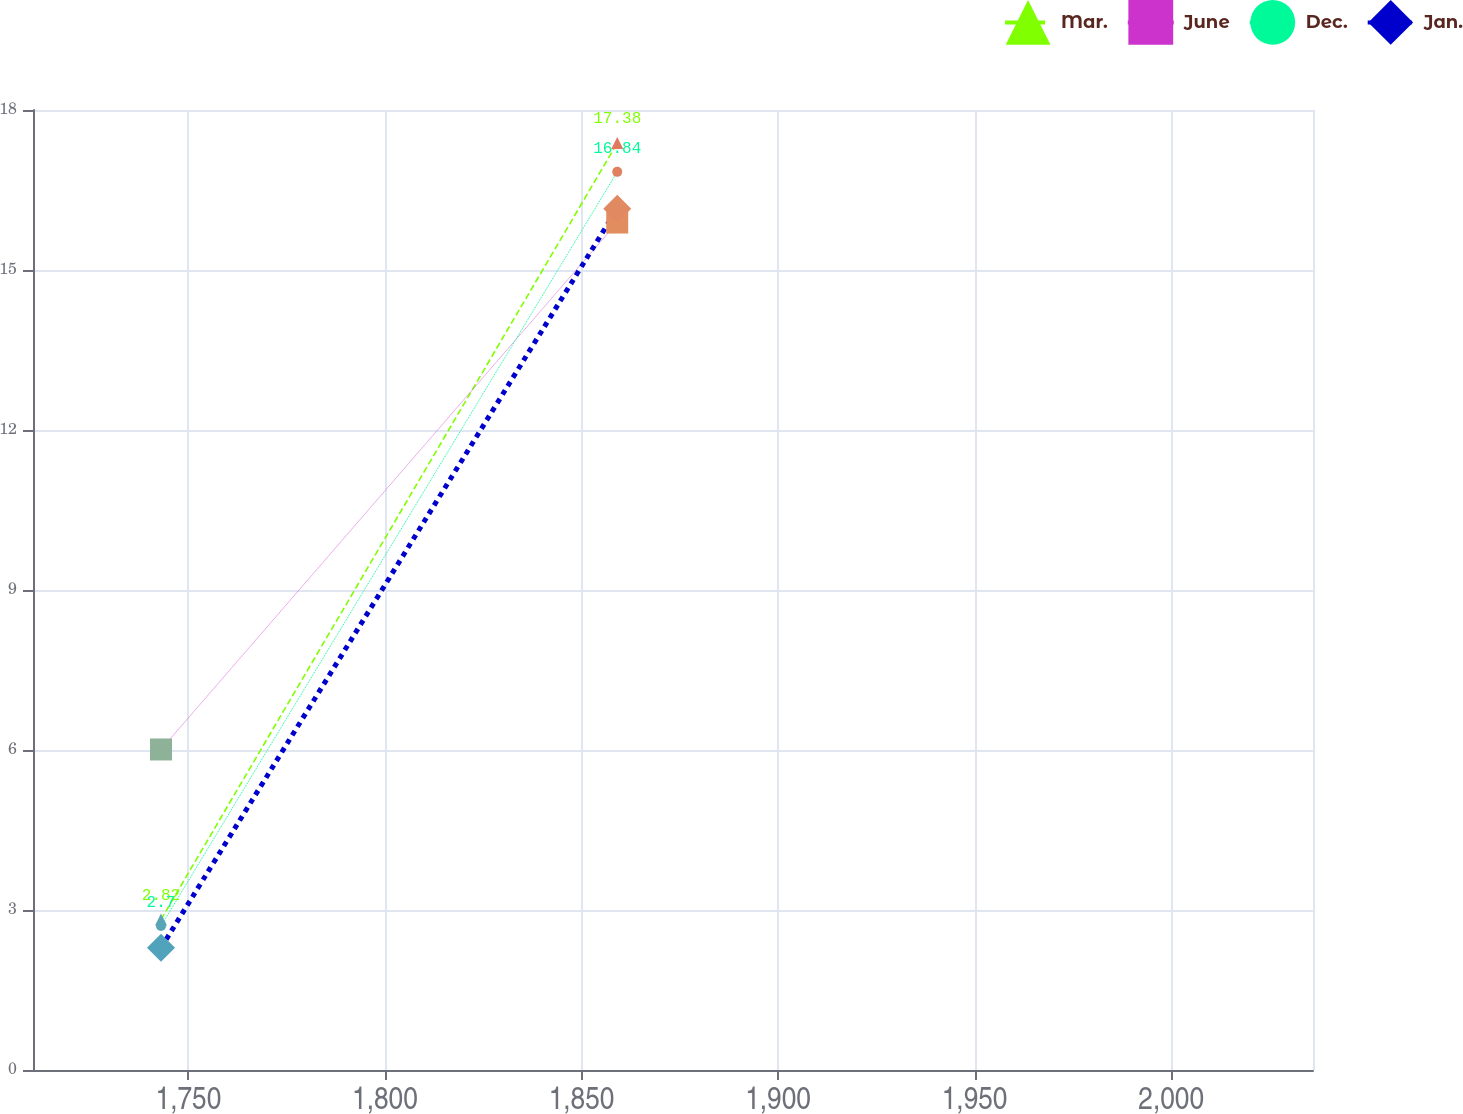Convert chart to OTSL. <chart><loc_0><loc_0><loc_500><loc_500><line_chart><ecel><fcel>Mar.<fcel>June<fcel>Dec.<fcel>Jan.<nl><fcel>1743.03<fcel>2.82<fcel>6.01<fcel>2.7<fcel>2.29<nl><fcel>1859.09<fcel>17.38<fcel>15.89<fcel>16.84<fcel>16.15<nl><fcel>2068.65<fcel>15.23<fcel>20.66<fcel>18.26<fcel>18.07<nl></chart> 